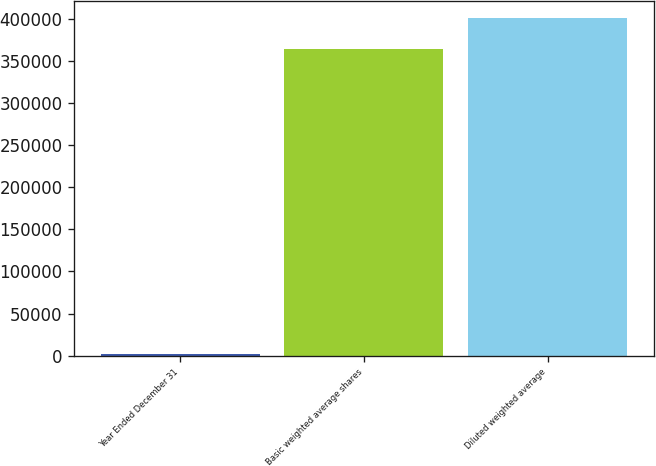Convert chart to OTSL. <chart><loc_0><loc_0><loc_500><loc_500><bar_chart><fcel>Year Ended December 31<fcel>Basic weighted average shares<fcel>Diluted weighted average<nl><fcel>2011<fcel>364147<fcel>400698<nl></chart> 